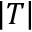Convert formula to latex. <formula><loc_0><loc_0><loc_500><loc_500>\left | T \right |</formula> 